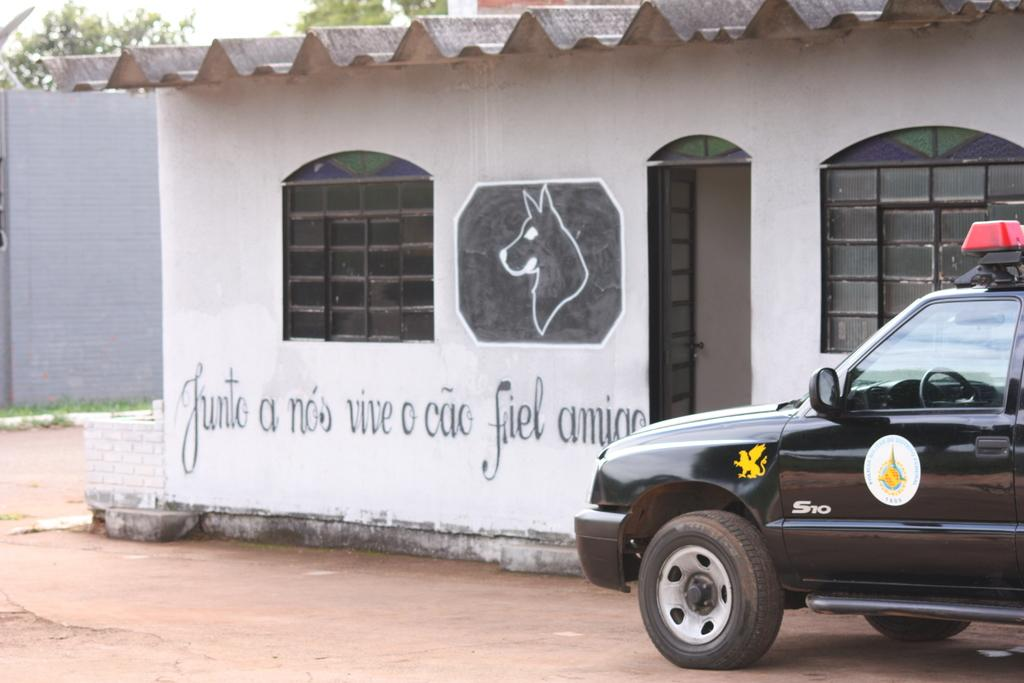What type of structure is visible in the image? There is a house in the image. What part of the house can be seen in the image? There is a door in the image. What material is present in the image? There is glass in the image. What type of vehicle is in the image? There is a black color car in the image. What type of vegetation is visible in the image? There are trees in the image. What is visible at the top of the image? The sky is visible at the top of the image. What type of apple is being served with the apparel in the image? There is no apple or apparel present in the image. What type of wine is being poured from the bottle in the image? There is no wine or bottle present in the image. 